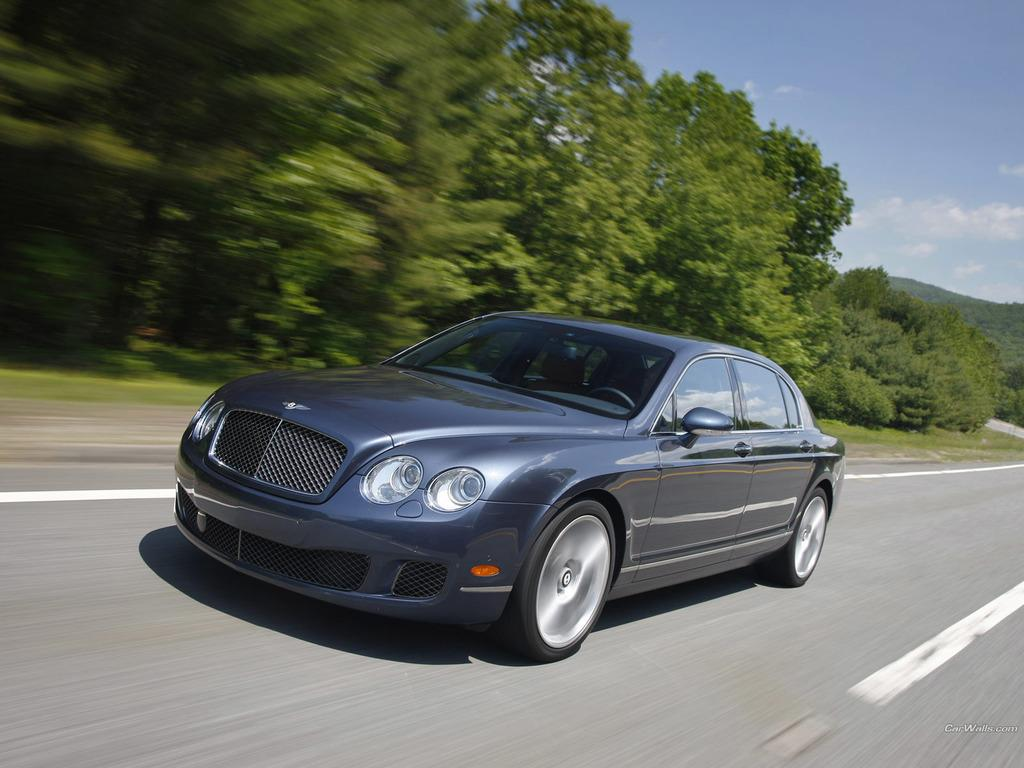What is the main subject of the image? There is a car on the road in the image. What can be seen on the left side of the image? There are trees on the left side of the image. How would you describe the sky in the image? The sky is cloudy in the image. What type of corn is growing in the image? There is no corn present in the image. What color is the prose in the image? The image does not contain any prose, as it is a visual medium. 